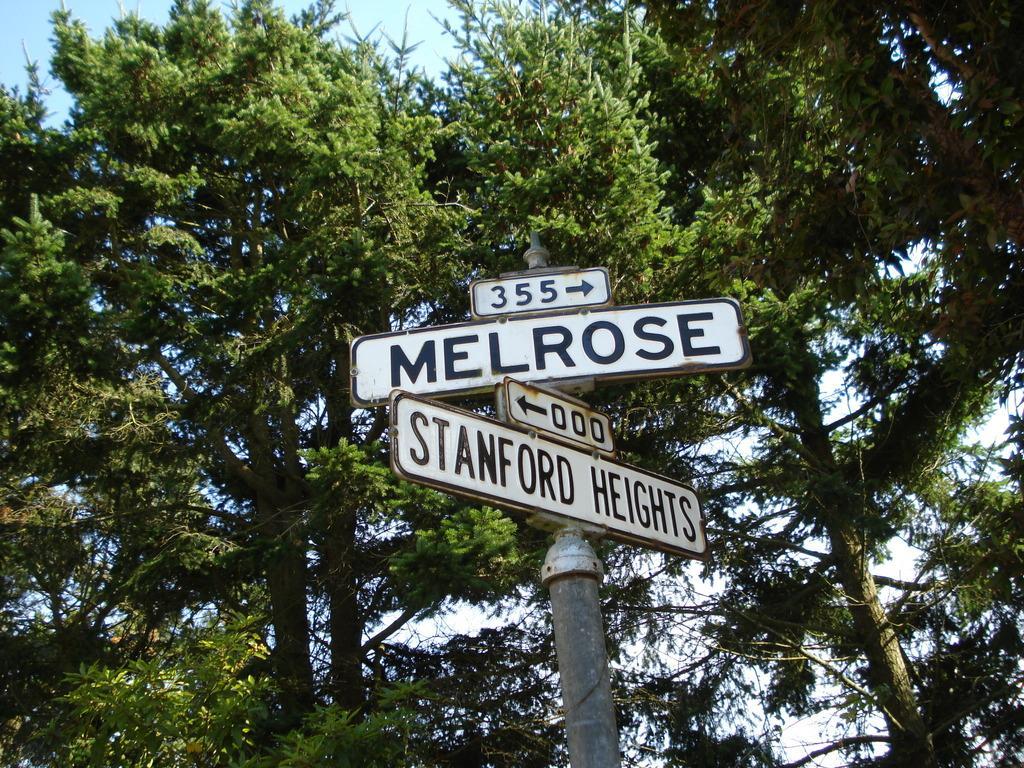Can you describe this image briefly? In this picture we can see direction boards and name boards, trees and in the background we can see the sky. 